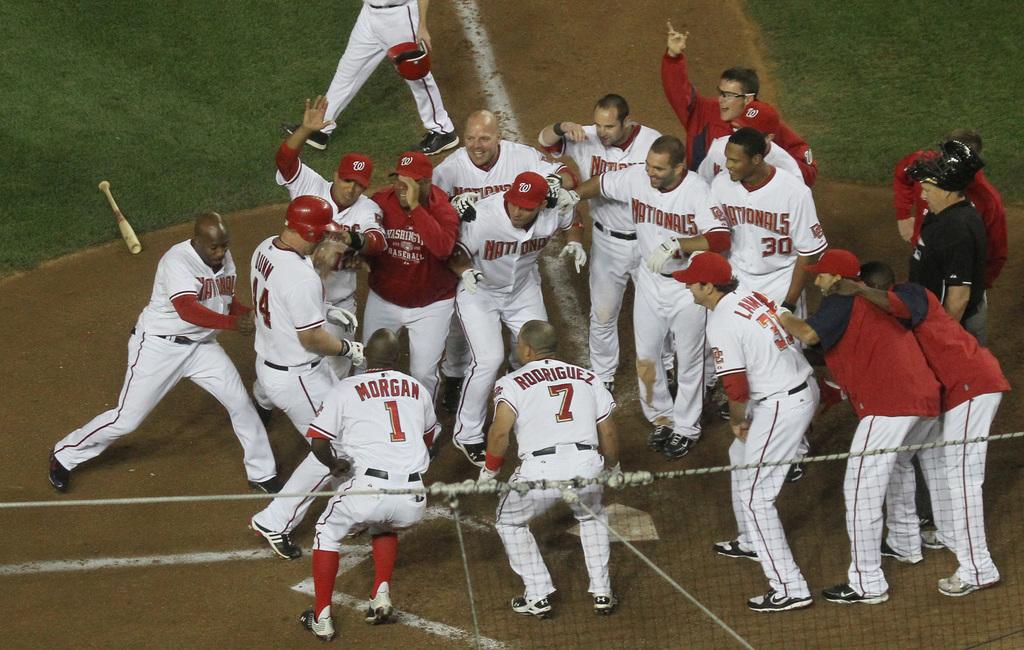What is the name of player 7?
Ensure brevity in your answer.  Rodriguez. 